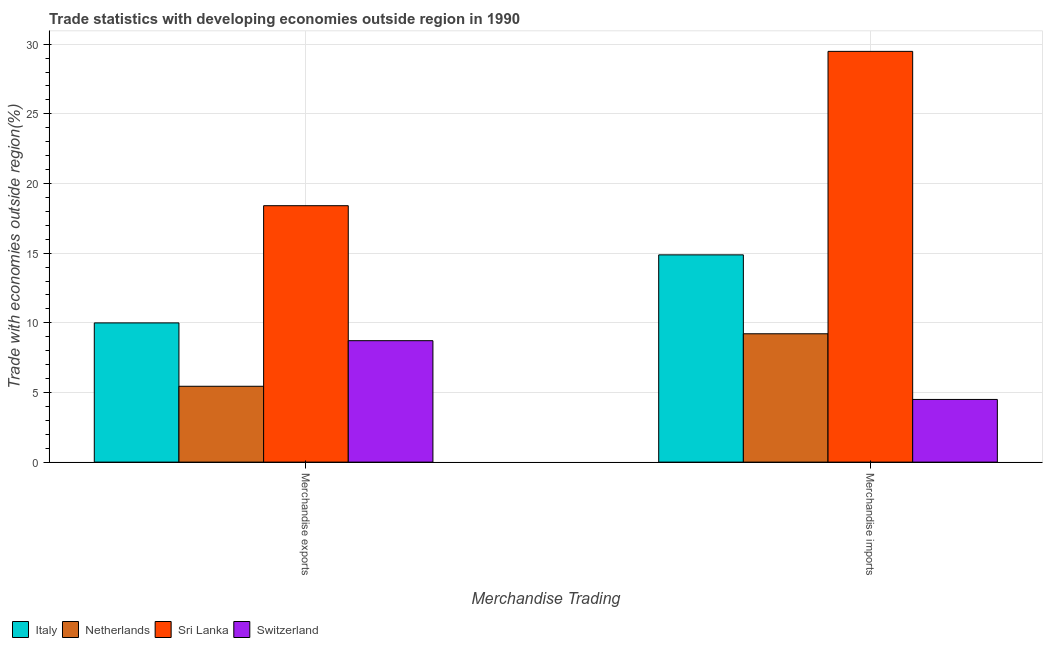Are the number of bars on each tick of the X-axis equal?
Provide a succinct answer. Yes. How many bars are there on the 2nd tick from the right?
Offer a terse response. 4. What is the merchandise exports in Sri Lanka?
Make the answer very short. 18.41. Across all countries, what is the maximum merchandise exports?
Offer a terse response. 18.41. Across all countries, what is the minimum merchandise imports?
Your answer should be very brief. 4.5. In which country was the merchandise exports maximum?
Offer a terse response. Sri Lanka. In which country was the merchandise exports minimum?
Offer a very short reply. Netherlands. What is the total merchandise imports in the graph?
Offer a very short reply. 58.07. What is the difference between the merchandise exports in Sri Lanka and that in Italy?
Keep it short and to the point. 8.41. What is the difference between the merchandise imports in Switzerland and the merchandise exports in Sri Lanka?
Your response must be concise. -13.91. What is the average merchandise imports per country?
Your answer should be compact. 14.52. What is the difference between the merchandise exports and merchandise imports in Sri Lanka?
Offer a terse response. -11.08. What is the ratio of the merchandise exports in Switzerland to that in Italy?
Make the answer very short. 0.87. In how many countries, is the merchandise imports greater than the average merchandise imports taken over all countries?
Offer a terse response. 2. What does the 4th bar from the left in Merchandise imports represents?
Your response must be concise. Switzerland. What does the 3rd bar from the right in Merchandise imports represents?
Provide a succinct answer. Netherlands. Are the values on the major ticks of Y-axis written in scientific E-notation?
Offer a terse response. No. Does the graph contain any zero values?
Ensure brevity in your answer.  No. Where does the legend appear in the graph?
Provide a succinct answer. Bottom left. How are the legend labels stacked?
Offer a terse response. Horizontal. What is the title of the graph?
Offer a terse response. Trade statistics with developing economies outside region in 1990. What is the label or title of the X-axis?
Your answer should be compact. Merchandise Trading. What is the label or title of the Y-axis?
Offer a terse response. Trade with economies outside region(%). What is the Trade with economies outside region(%) in Italy in Merchandise exports?
Ensure brevity in your answer.  9.99. What is the Trade with economies outside region(%) of Netherlands in Merchandise exports?
Make the answer very short. 5.44. What is the Trade with economies outside region(%) of Sri Lanka in Merchandise exports?
Keep it short and to the point. 18.41. What is the Trade with economies outside region(%) of Switzerland in Merchandise exports?
Provide a succinct answer. 8.72. What is the Trade with economies outside region(%) in Italy in Merchandise imports?
Offer a very short reply. 14.88. What is the Trade with economies outside region(%) in Netherlands in Merchandise imports?
Provide a succinct answer. 9.21. What is the Trade with economies outside region(%) of Sri Lanka in Merchandise imports?
Provide a succinct answer. 29.48. What is the Trade with economies outside region(%) in Switzerland in Merchandise imports?
Keep it short and to the point. 4.5. Across all Merchandise Trading, what is the maximum Trade with economies outside region(%) of Italy?
Make the answer very short. 14.88. Across all Merchandise Trading, what is the maximum Trade with economies outside region(%) in Netherlands?
Give a very brief answer. 9.21. Across all Merchandise Trading, what is the maximum Trade with economies outside region(%) in Sri Lanka?
Make the answer very short. 29.48. Across all Merchandise Trading, what is the maximum Trade with economies outside region(%) of Switzerland?
Offer a very short reply. 8.72. Across all Merchandise Trading, what is the minimum Trade with economies outside region(%) of Italy?
Offer a terse response. 9.99. Across all Merchandise Trading, what is the minimum Trade with economies outside region(%) of Netherlands?
Offer a terse response. 5.44. Across all Merchandise Trading, what is the minimum Trade with economies outside region(%) in Sri Lanka?
Offer a terse response. 18.41. Across all Merchandise Trading, what is the minimum Trade with economies outside region(%) in Switzerland?
Give a very brief answer. 4.5. What is the total Trade with economies outside region(%) in Italy in the graph?
Your answer should be compact. 24.87. What is the total Trade with economies outside region(%) in Netherlands in the graph?
Give a very brief answer. 14.66. What is the total Trade with economies outside region(%) in Sri Lanka in the graph?
Ensure brevity in your answer.  47.89. What is the total Trade with economies outside region(%) in Switzerland in the graph?
Provide a short and direct response. 13.22. What is the difference between the Trade with economies outside region(%) in Italy in Merchandise exports and that in Merchandise imports?
Your answer should be compact. -4.88. What is the difference between the Trade with economies outside region(%) of Netherlands in Merchandise exports and that in Merchandise imports?
Your answer should be very brief. -3.77. What is the difference between the Trade with economies outside region(%) in Sri Lanka in Merchandise exports and that in Merchandise imports?
Offer a very short reply. -11.08. What is the difference between the Trade with economies outside region(%) in Switzerland in Merchandise exports and that in Merchandise imports?
Offer a very short reply. 4.22. What is the difference between the Trade with economies outside region(%) in Italy in Merchandise exports and the Trade with economies outside region(%) in Netherlands in Merchandise imports?
Ensure brevity in your answer.  0.78. What is the difference between the Trade with economies outside region(%) in Italy in Merchandise exports and the Trade with economies outside region(%) in Sri Lanka in Merchandise imports?
Offer a very short reply. -19.49. What is the difference between the Trade with economies outside region(%) of Italy in Merchandise exports and the Trade with economies outside region(%) of Switzerland in Merchandise imports?
Your response must be concise. 5.49. What is the difference between the Trade with economies outside region(%) in Netherlands in Merchandise exports and the Trade with economies outside region(%) in Sri Lanka in Merchandise imports?
Provide a succinct answer. -24.04. What is the difference between the Trade with economies outside region(%) of Netherlands in Merchandise exports and the Trade with economies outside region(%) of Switzerland in Merchandise imports?
Your answer should be very brief. 0.95. What is the difference between the Trade with economies outside region(%) of Sri Lanka in Merchandise exports and the Trade with economies outside region(%) of Switzerland in Merchandise imports?
Your answer should be compact. 13.91. What is the average Trade with economies outside region(%) of Italy per Merchandise Trading?
Keep it short and to the point. 12.43. What is the average Trade with economies outside region(%) of Netherlands per Merchandise Trading?
Offer a very short reply. 7.33. What is the average Trade with economies outside region(%) in Sri Lanka per Merchandise Trading?
Keep it short and to the point. 23.94. What is the average Trade with economies outside region(%) of Switzerland per Merchandise Trading?
Keep it short and to the point. 6.61. What is the difference between the Trade with economies outside region(%) of Italy and Trade with economies outside region(%) of Netherlands in Merchandise exports?
Keep it short and to the point. 4.55. What is the difference between the Trade with economies outside region(%) in Italy and Trade with economies outside region(%) in Sri Lanka in Merchandise exports?
Your response must be concise. -8.41. What is the difference between the Trade with economies outside region(%) in Italy and Trade with economies outside region(%) in Switzerland in Merchandise exports?
Make the answer very short. 1.28. What is the difference between the Trade with economies outside region(%) in Netherlands and Trade with economies outside region(%) in Sri Lanka in Merchandise exports?
Provide a succinct answer. -12.96. What is the difference between the Trade with economies outside region(%) in Netherlands and Trade with economies outside region(%) in Switzerland in Merchandise exports?
Ensure brevity in your answer.  -3.27. What is the difference between the Trade with economies outside region(%) of Sri Lanka and Trade with economies outside region(%) of Switzerland in Merchandise exports?
Give a very brief answer. 9.69. What is the difference between the Trade with economies outside region(%) of Italy and Trade with economies outside region(%) of Netherlands in Merchandise imports?
Make the answer very short. 5.66. What is the difference between the Trade with economies outside region(%) in Italy and Trade with economies outside region(%) in Sri Lanka in Merchandise imports?
Your response must be concise. -14.61. What is the difference between the Trade with economies outside region(%) of Italy and Trade with economies outside region(%) of Switzerland in Merchandise imports?
Provide a short and direct response. 10.38. What is the difference between the Trade with economies outside region(%) of Netherlands and Trade with economies outside region(%) of Sri Lanka in Merchandise imports?
Your answer should be compact. -20.27. What is the difference between the Trade with economies outside region(%) of Netherlands and Trade with economies outside region(%) of Switzerland in Merchandise imports?
Your answer should be very brief. 4.71. What is the difference between the Trade with economies outside region(%) of Sri Lanka and Trade with economies outside region(%) of Switzerland in Merchandise imports?
Your answer should be compact. 24.98. What is the ratio of the Trade with economies outside region(%) in Italy in Merchandise exports to that in Merchandise imports?
Provide a succinct answer. 0.67. What is the ratio of the Trade with economies outside region(%) of Netherlands in Merchandise exports to that in Merchandise imports?
Your answer should be compact. 0.59. What is the ratio of the Trade with economies outside region(%) of Sri Lanka in Merchandise exports to that in Merchandise imports?
Give a very brief answer. 0.62. What is the ratio of the Trade with economies outside region(%) of Switzerland in Merchandise exports to that in Merchandise imports?
Offer a very short reply. 1.94. What is the difference between the highest and the second highest Trade with economies outside region(%) of Italy?
Your response must be concise. 4.88. What is the difference between the highest and the second highest Trade with economies outside region(%) in Netherlands?
Offer a terse response. 3.77. What is the difference between the highest and the second highest Trade with economies outside region(%) of Sri Lanka?
Offer a terse response. 11.08. What is the difference between the highest and the second highest Trade with economies outside region(%) in Switzerland?
Offer a very short reply. 4.22. What is the difference between the highest and the lowest Trade with economies outside region(%) in Italy?
Provide a succinct answer. 4.88. What is the difference between the highest and the lowest Trade with economies outside region(%) of Netherlands?
Ensure brevity in your answer.  3.77. What is the difference between the highest and the lowest Trade with economies outside region(%) in Sri Lanka?
Offer a very short reply. 11.08. What is the difference between the highest and the lowest Trade with economies outside region(%) in Switzerland?
Ensure brevity in your answer.  4.22. 